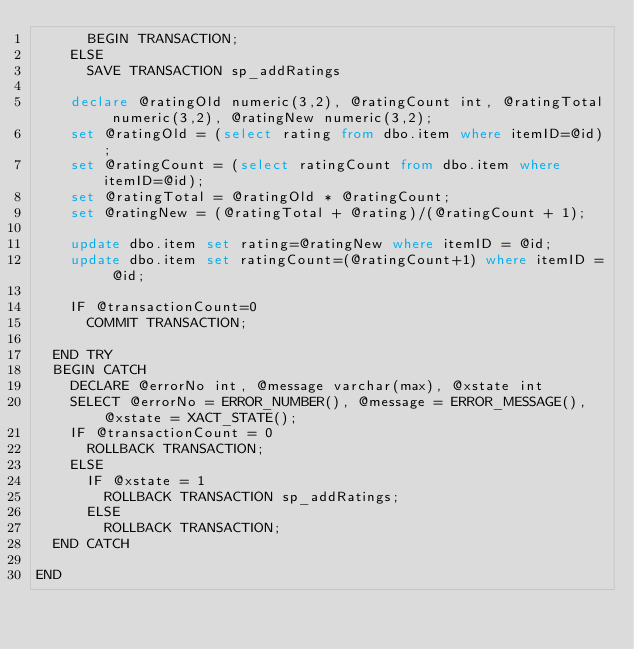<code> <loc_0><loc_0><loc_500><loc_500><_SQL_>			BEGIN TRANSACTION;
		ELSE
			SAVE TRANSACTION sp_addRatings

    declare @ratingOld numeric(3,2), @ratingCount int, @ratingTotal numeric(3,2), @ratingNew numeric(3,2);
    set @ratingOld = (select rating from dbo.item where itemID=@id);
    set @ratingCount = (select ratingCount from dbo.item where itemID=@id);
    set @ratingTotal = @ratingOld * @ratingCount;
    set @ratingNew = (@ratingTotal + @rating)/(@ratingCount + 1);

		update dbo.item set rating=@ratingNew where itemID = @id;
    update dbo.item set ratingCount=(@ratingCount+1) where itemID = @id;

		IF @transactionCount=0
			COMMIT TRANSACTION;

	END TRY
	BEGIN CATCH
		DECLARE @errorNo int, @message varchar(max), @xstate int
		SELECT @errorNo = ERROR_NUMBER(), @message = ERROR_MESSAGE(), @xstate = XACT_STATE();
		IF @transactionCount = 0
			ROLLBACK TRANSACTION;
		ELSE
			IF @xstate = 1
				ROLLBACK TRANSACTION sp_addRatings;
			ELSE
				ROLLBACK TRANSACTION;
	END CATCH

END
</code> 